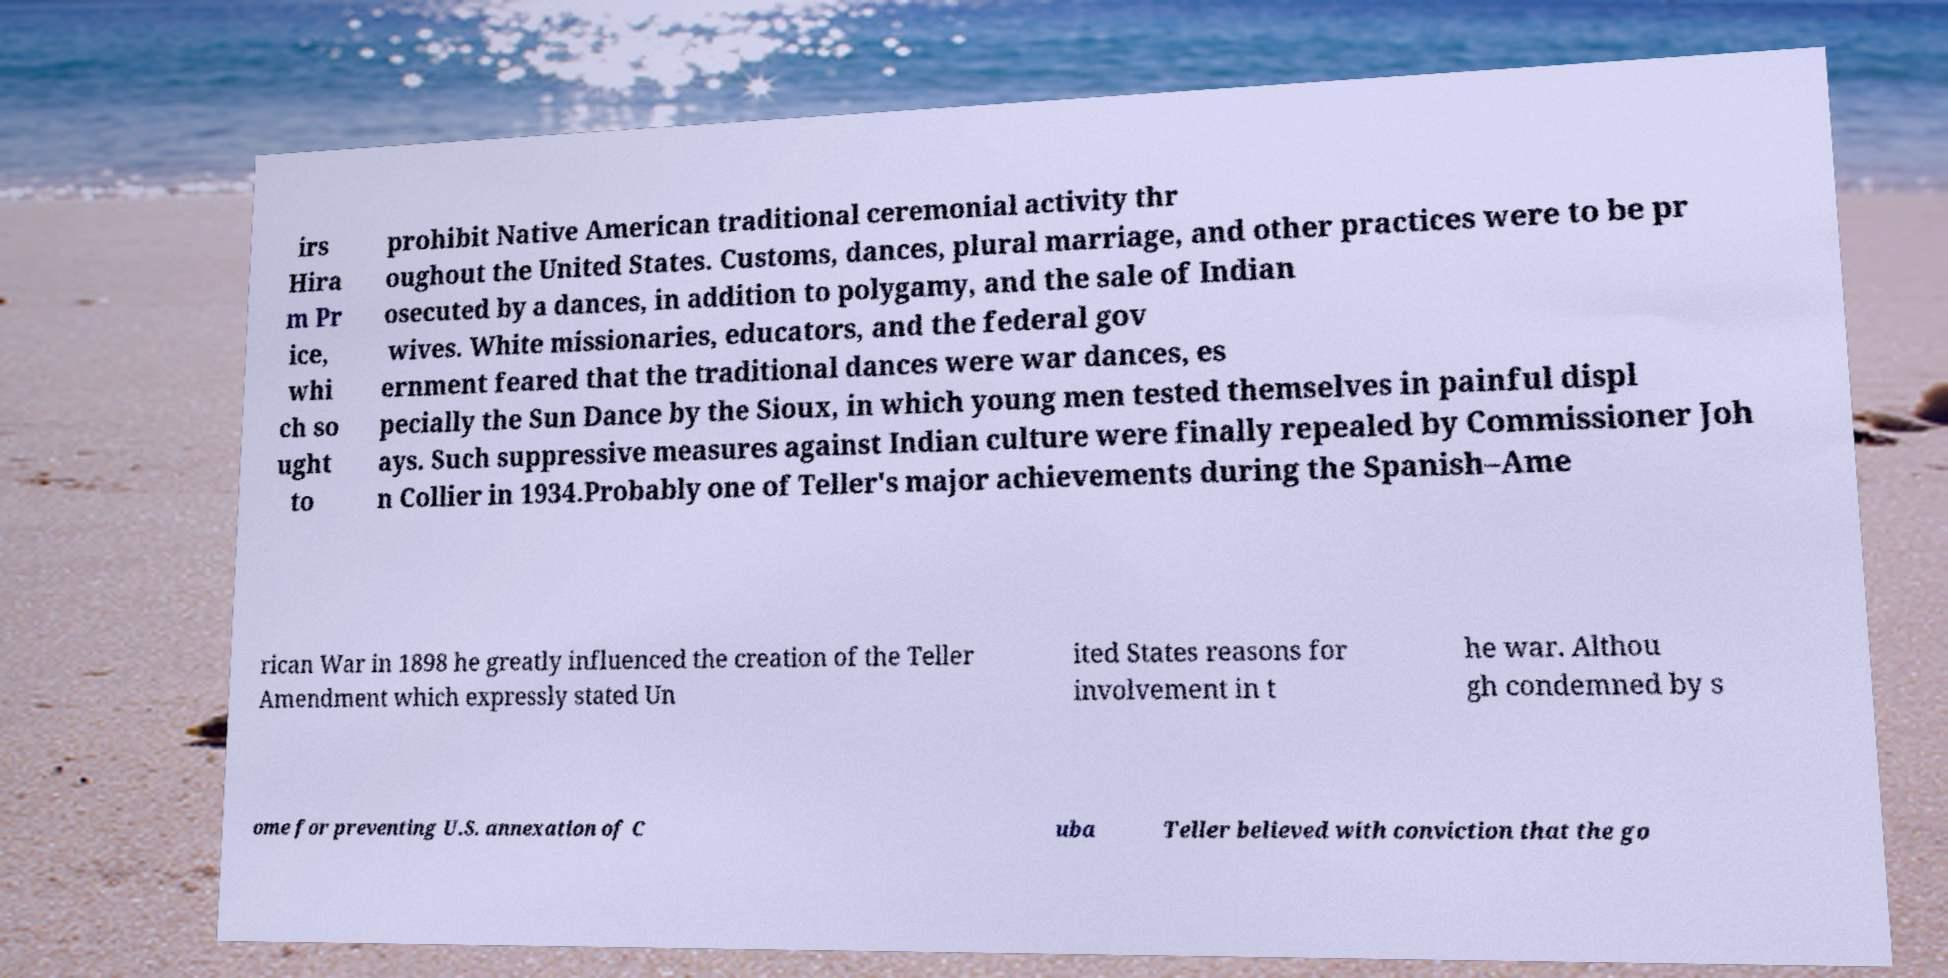Could you assist in decoding the text presented in this image and type it out clearly? irs Hira m Pr ice, whi ch so ught to prohibit Native American traditional ceremonial activity thr oughout the United States. Customs, dances, plural marriage, and other practices were to be pr osecuted by a dances, in addition to polygamy, and the sale of Indian wives. White missionaries, educators, and the federal gov ernment feared that the traditional dances were war dances, es pecially the Sun Dance by the Sioux, in which young men tested themselves in painful displ ays. Such suppressive measures against Indian culture were finally repealed by Commissioner Joh n Collier in 1934.Probably one of Teller's major achievements during the Spanish–Ame rican War in 1898 he greatly influenced the creation of the Teller Amendment which expressly stated Un ited States reasons for involvement in t he war. Althou gh condemned by s ome for preventing U.S. annexation of C uba Teller believed with conviction that the go 